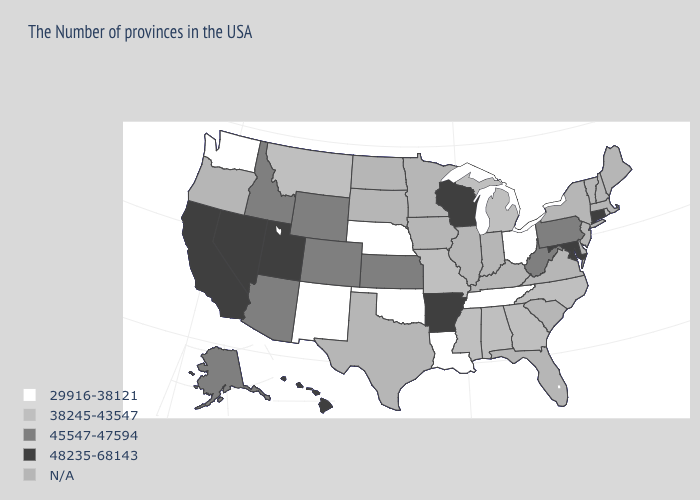Name the states that have a value in the range 29916-38121?
Concise answer only. Ohio, Tennessee, Louisiana, Nebraska, Oklahoma, New Mexico, Washington. Does Maryland have the highest value in the USA?
Give a very brief answer. Yes. Name the states that have a value in the range 48235-68143?
Write a very short answer. Connecticut, Maryland, Wisconsin, Arkansas, Utah, Nevada, California, Hawaii. Does Rhode Island have the lowest value in the Northeast?
Quick response, please. Yes. Which states have the lowest value in the Northeast?
Short answer required. Rhode Island. Which states have the lowest value in the MidWest?
Write a very short answer. Ohio, Nebraska. What is the highest value in the USA?
Quick response, please. 48235-68143. How many symbols are there in the legend?
Answer briefly. 5. What is the value of North Carolina?
Give a very brief answer. 38245-43547. Name the states that have a value in the range 45547-47594?
Keep it brief. Pennsylvania, West Virginia, Kansas, Wyoming, Colorado, Arizona, Idaho, Alaska. What is the value of New Mexico?
Write a very short answer. 29916-38121. What is the value of Georgia?
Keep it brief. 38245-43547. What is the value of North Dakota?
Keep it brief. N/A. 